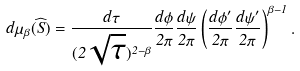Convert formula to latex. <formula><loc_0><loc_0><loc_500><loc_500>d \mu _ { \beta } ( \widehat { S } ) = \frac { d \tau } { ( 2 \sqrt { \tau } ) ^ { 2 - \beta } } \frac { d \phi } { 2 \pi } \frac { d \psi } { 2 \pi } \left ( \frac { d \phi ^ { \prime } } { 2 \pi } \frac { d \psi ^ { \prime } } { 2 \pi } \right ) ^ { \beta - 1 } .</formula> 